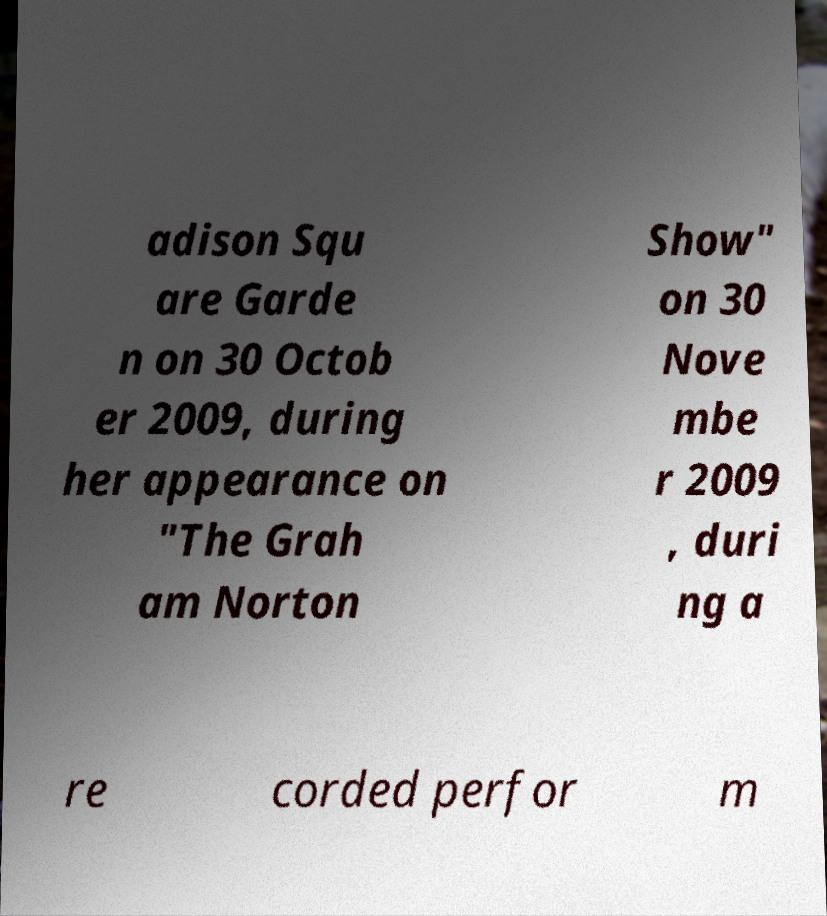Could you extract and type out the text from this image? adison Squ are Garde n on 30 Octob er 2009, during her appearance on "The Grah am Norton Show" on 30 Nove mbe r 2009 , duri ng a re corded perfor m 